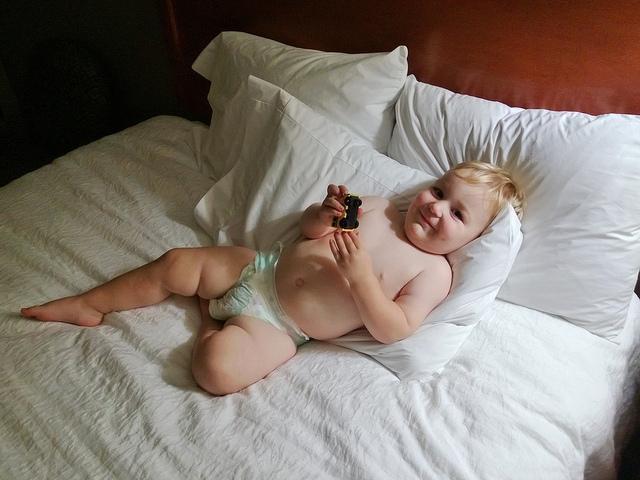How many boats with a roof are on the water?
Give a very brief answer. 0. 